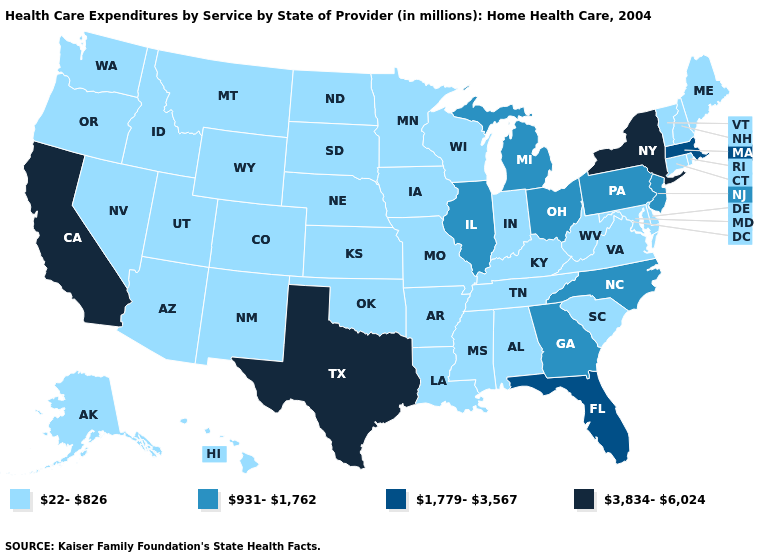What is the lowest value in the West?
Give a very brief answer. 22-826. Does the first symbol in the legend represent the smallest category?
Answer briefly. Yes. Name the states that have a value in the range 22-826?
Short answer required. Alabama, Alaska, Arizona, Arkansas, Colorado, Connecticut, Delaware, Hawaii, Idaho, Indiana, Iowa, Kansas, Kentucky, Louisiana, Maine, Maryland, Minnesota, Mississippi, Missouri, Montana, Nebraska, Nevada, New Hampshire, New Mexico, North Dakota, Oklahoma, Oregon, Rhode Island, South Carolina, South Dakota, Tennessee, Utah, Vermont, Virginia, Washington, West Virginia, Wisconsin, Wyoming. Name the states that have a value in the range 1,779-3,567?
Write a very short answer. Florida, Massachusetts. What is the highest value in the USA?
Keep it brief. 3,834-6,024. Name the states that have a value in the range 22-826?
Keep it brief. Alabama, Alaska, Arizona, Arkansas, Colorado, Connecticut, Delaware, Hawaii, Idaho, Indiana, Iowa, Kansas, Kentucky, Louisiana, Maine, Maryland, Minnesota, Mississippi, Missouri, Montana, Nebraska, Nevada, New Hampshire, New Mexico, North Dakota, Oklahoma, Oregon, Rhode Island, South Carolina, South Dakota, Tennessee, Utah, Vermont, Virginia, Washington, West Virginia, Wisconsin, Wyoming. Among the states that border New Jersey , does New York have the lowest value?
Short answer required. No. Name the states that have a value in the range 1,779-3,567?
Be succinct. Florida, Massachusetts. What is the value of Indiana?
Write a very short answer. 22-826. How many symbols are there in the legend?
Short answer required. 4. What is the highest value in states that border Iowa?
Be succinct. 931-1,762. Among the states that border New Jersey , does Delaware have the lowest value?
Be succinct. Yes. What is the value of Wisconsin?
Write a very short answer. 22-826. What is the lowest value in the USA?
Quick response, please. 22-826. 